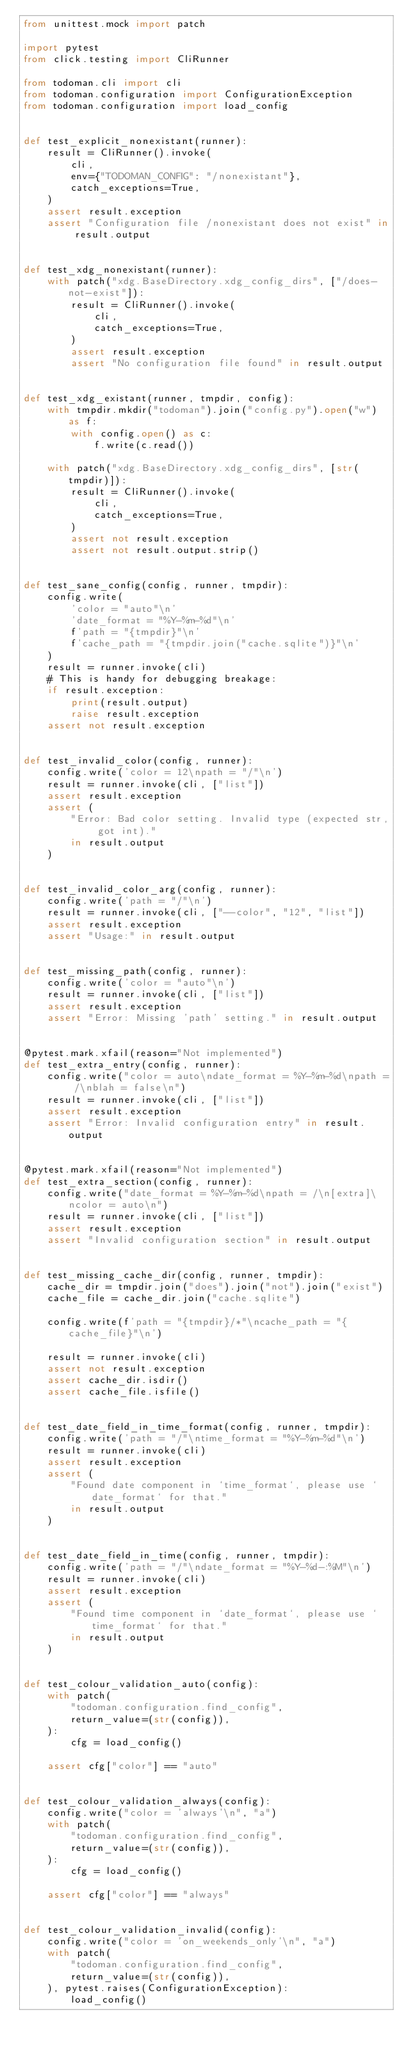Convert code to text. <code><loc_0><loc_0><loc_500><loc_500><_Python_>from unittest.mock import patch

import pytest
from click.testing import CliRunner

from todoman.cli import cli
from todoman.configuration import ConfigurationException
from todoman.configuration import load_config


def test_explicit_nonexistant(runner):
    result = CliRunner().invoke(
        cli,
        env={"TODOMAN_CONFIG": "/nonexistant"},
        catch_exceptions=True,
    )
    assert result.exception
    assert "Configuration file /nonexistant does not exist" in result.output


def test_xdg_nonexistant(runner):
    with patch("xdg.BaseDirectory.xdg_config_dirs", ["/does-not-exist"]):
        result = CliRunner().invoke(
            cli,
            catch_exceptions=True,
        )
        assert result.exception
        assert "No configuration file found" in result.output


def test_xdg_existant(runner, tmpdir, config):
    with tmpdir.mkdir("todoman").join("config.py").open("w") as f:
        with config.open() as c:
            f.write(c.read())

    with patch("xdg.BaseDirectory.xdg_config_dirs", [str(tmpdir)]):
        result = CliRunner().invoke(
            cli,
            catch_exceptions=True,
        )
        assert not result.exception
        assert not result.output.strip()


def test_sane_config(config, runner, tmpdir):
    config.write(
        'color = "auto"\n'
        'date_format = "%Y-%m-%d"\n'
        f'path = "{tmpdir}"\n'
        f'cache_path = "{tmpdir.join("cache.sqlite")}"\n'
    )
    result = runner.invoke(cli)
    # This is handy for debugging breakage:
    if result.exception:
        print(result.output)
        raise result.exception
    assert not result.exception


def test_invalid_color(config, runner):
    config.write('color = 12\npath = "/"\n')
    result = runner.invoke(cli, ["list"])
    assert result.exception
    assert (
        "Error: Bad color setting. Invalid type (expected str, got int)."
        in result.output
    )


def test_invalid_color_arg(config, runner):
    config.write('path = "/"\n')
    result = runner.invoke(cli, ["--color", "12", "list"])
    assert result.exception
    assert "Usage:" in result.output


def test_missing_path(config, runner):
    config.write('color = "auto"\n')
    result = runner.invoke(cli, ["list"])
    assert result.exception
    assert "Error: Missing 'path' setting." in result.output


@pytest.mark.xfail(reason="Not implemented")
def test_extra_entry(config, runner):
    config.write("color = auto\ndate_format = %Y-%m-%d\npath = /\nblah = false\n")
    result = runner.invoke(cli, ["list"])
    assert result.exception
    assert "Error: Invalid configuration entry" in result.output


@pytest.mark.xfail(reason="Not implemented")
def test_extra_section(config, runner):
    config.write("date_format = %Y-%m-%d\npath = /\n[extra]\ncolor = auto\n")
    result = runner.invoke(cli, ["list"])
    assert result.exception
    assert "Invalid configuration section" in result.output


def test_missing_cache_dir(config, runner, tmpdir):
    cache_dir = tmpdir.join("does").join("not").join("exist")
    cache_file = cache_dir.join("cache.sqlite")

    config.write(f'path = "{tmpdir}/*"\ncache_path = "{cache_file}"\n')

    result = runner.invoke(cli)
    assert not result.exception
    assert cache_dir.isdir()
    assert cache_file.isfile()


def test_date_field_in_time_format(config, runner, tmpdir):
    config.write('path = "/"\ntime_format = "%Y-%m-%d"\n')
    result = runner.invoke(cli)
    assert result.exception
    assert (
        "Found date component in `time_format`, please use `date_format` for that."
        in result.output
    )


def test_date_field_in_time(config, runner, tmpdir):
    config.write('path = "/"\ndate_format = "%Y-%d-:%M"\n')
    result = runner.invoke(cli)
    assert result.exception
    assert (
        "Found time component in `date_format`, please use `time_format` for that."
        in result.output
    )


def test_colour_validation_auto(config):
    with patch(
        "todoman.configuration.find_config",
        return_value=(str(config)),
    ):
        cfg = load_config()

    assert cfg["color"] == "auto"


def test_colour_validation_always(config):
    config.write("color = 'always'\n", "a")
    with patch(
        "todoman.configuration.find_config",
        return_value=(str(config)),
    ):
        cfg = load_config()

    assert cfg["color"] == "always"


def test_colour_validation_invalid(config):
    config.write("color = 'on_weekends_only'\n", "a")
    with patch(
        "todoman.configuration.find_config",
        return_value=(str(config)),
    ), pytest.raises(ConfigurationException):
        load_config()
</code> 